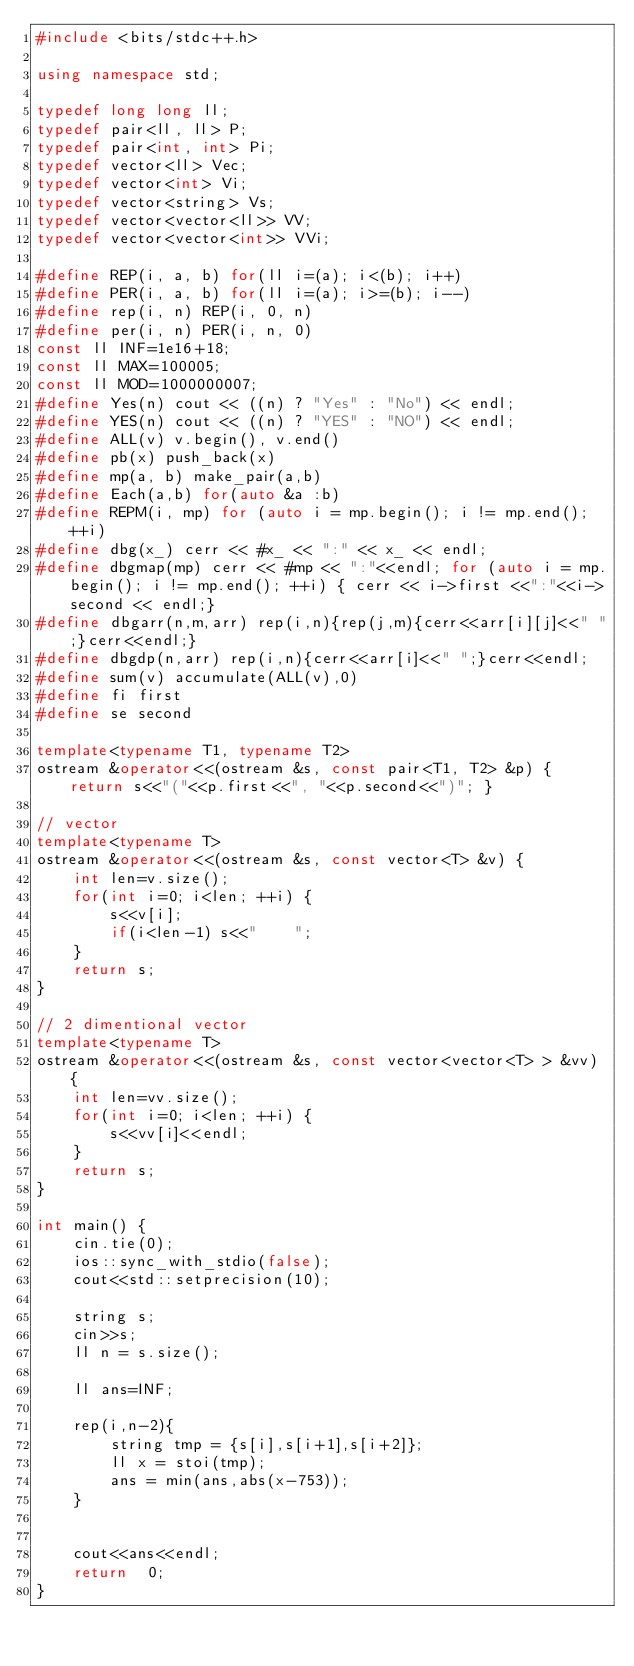<code> <loc_0><loc_0><loc_500><loc_500><_C++_>#include <bits/stdc++.h>

using namespace std;

typedef long long ll;
typedef pair<ll, ll> P;
typedef pair<int, int> Pi;
typedef vector<ll> Vec;
typedef vector<int> Vi;
typedef vector<string> Vs;
typedef vector<vector<ll>> VV;
typedef vector<vector<int>> VVi;

#define REP(i, a, b) for(ll i=(a); i<(b); i++)
#define PER(i, a, b) for(ll i=(a); i>=(b); i--)
#define rep(i, n) REP(i, 0, n)
#define per(i, n) PER(i, n, 0)
const ll INF=1e16+18;
const ll MAX=100005;
const ll MOD=1000000007;
#define Yes(n) cout << ((n) ? "Yes" : "No") << endl;
#define YES(n) cout << ((n) ? "YES" : "NO") << endl;
#define ALL(v) v.begin(), v.end()
#define pb(x) push_back(x)
#define mp(a, b) make_pair(a,b)
#define Each(a,b) for(auto &a :b)
#define REPM(i, mp) for (auto i = mp.begin(); i != mp.end(); ++i)
#define dbg(x_) cerr << #x_ << ":" << x_ << endl;
#define dbgmap(mp) cerr << #mp << ":"<<endl; for (auto i = mp.begin(); i != mp.end(); ++i) { cerr << i->first <<":"<<i->second << endl;}
#define dbgarr(n,m,arr) rep(i,n){rep(j,m){cerr<<arr[i][j]<<" ";}cerr<<endl;}
#define dbgdp(n,arr) rep(i,n){cerr<<arr[i]<<" ";}cerr<<endl;
#define sum(v) accumulate(ALL(v),0)
#define fi first
#define se second

template<typename T1, typename T2>
ostream &operator<<(ostream &s, const pair<T1, T2> &p) { return s<<"("<<p.first<<", "<<p.second<<")"; }

// vector
template<typename T>
ostream &operator<<(ostream &s, const vector<T> &v) {
    int len=v.size();
    for(int i=0; i<len; ++i) {
        s<<v[i];
        if(i<len-1) s<<"	";
    }
    return s;
}

// 2 dimentional vector
template<typename T>
ostream &operator<<(ostream &s, const vector<vector<T> > &vv) {
    int len=vv.size();
    for(int i=0; i<len; ++i) {
        s<<vv[i]<<endl;
    }
    return s;
}

int main() {
    cin.tie(0);
    ios::sync_with_stdio(false);
    cout<<std::setprecision(10);

    string s;
    cin>>s;
    ll n = s.size();

    ll ans=INF;

    rep(i,n-2){
        string tmp = {s[i],s[i+1],s[i+2]};
        ll x = stoi(tmp);
        ans = min(ans,abs(x-753));
    }


    cout<<ans<<endl;
    return  0;
}
</code> 